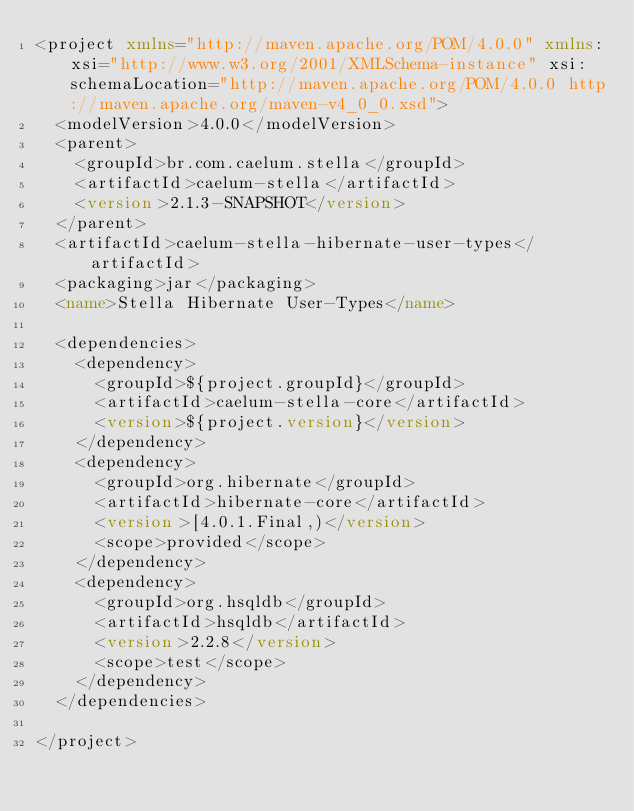<code> <loc_0><loc_0><loc_500><loc_500><_XML_><project xmlns="http://maven.apache.org/POM/4.0.0" xmlns:xsi="http://www.w3.org/2001/XMLSchema-instance" xsi:schemaLocation="http://maven.apache.org/POM/4.0.0 http://maven.apache.org/maven-v4_0_0.xsd">
	<modelVersion>4.0.0</modelVersion>
	<parent>
		<groupId>br.com.caelum.stella</groupId>
		<artifactId>caelum-stella</artifactId>
		<version>2.1.3-SNAPSHOT</version>
	</parent>
	<artifactId>caelum-stella-hibernate-user-types</artifactId>
	<packaging>jar</packaging>
	<name>Stella Hibernate User-Types</name>

	<dependencies>
		<dependency>
			<groupId>${project.groupId}</groupId>
			<artifactId>caelum-stella-core</artifactId>
			<version>${project.version}</version>
		</dependency>
		<dependency>
			<groupId>org.hibernate</groupId>
			<artifactId>hibernate-core</artifactId>
			<version>[4.0.1.Final,)</version>
			<scope>provided</scope>
		</dependency>
		<dependency>
			<groupId>org.hsqldb</groupId>
			<artifactId>hsqldb</artifactId>
			<version>2.2.8</version>
			<scope>test</scope>
		</dependency>
	</dependencies>

</project>
</code> 